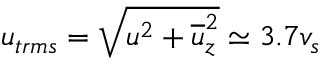Convert formula to latex. <formula><loc_0><loc_0><loc_500><loc_500>u _ { t r m s } = \sqrt { u ^ { 2 } + \overline { u } _ { z } ^ { 2 } } \simeq 3 . 7 v _ { s }</formula> 